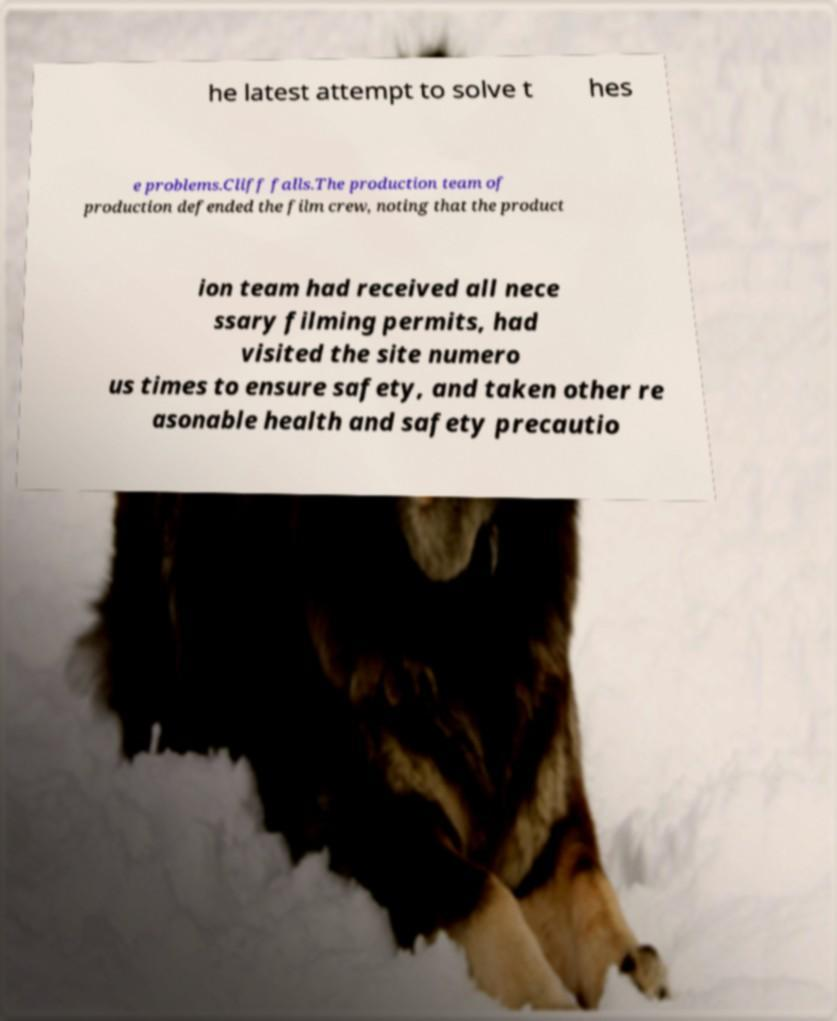Could you assist in decoding the text presented in this image and type it out clearly? he latest attempt to solve t hes e problems.Cliff falls.The production team of production defended the film crew, noting that the product ion team had received all nece ssary filming permits, had visited the site numero us times to ensure safety, and taken other re asonable health and safety precautio 